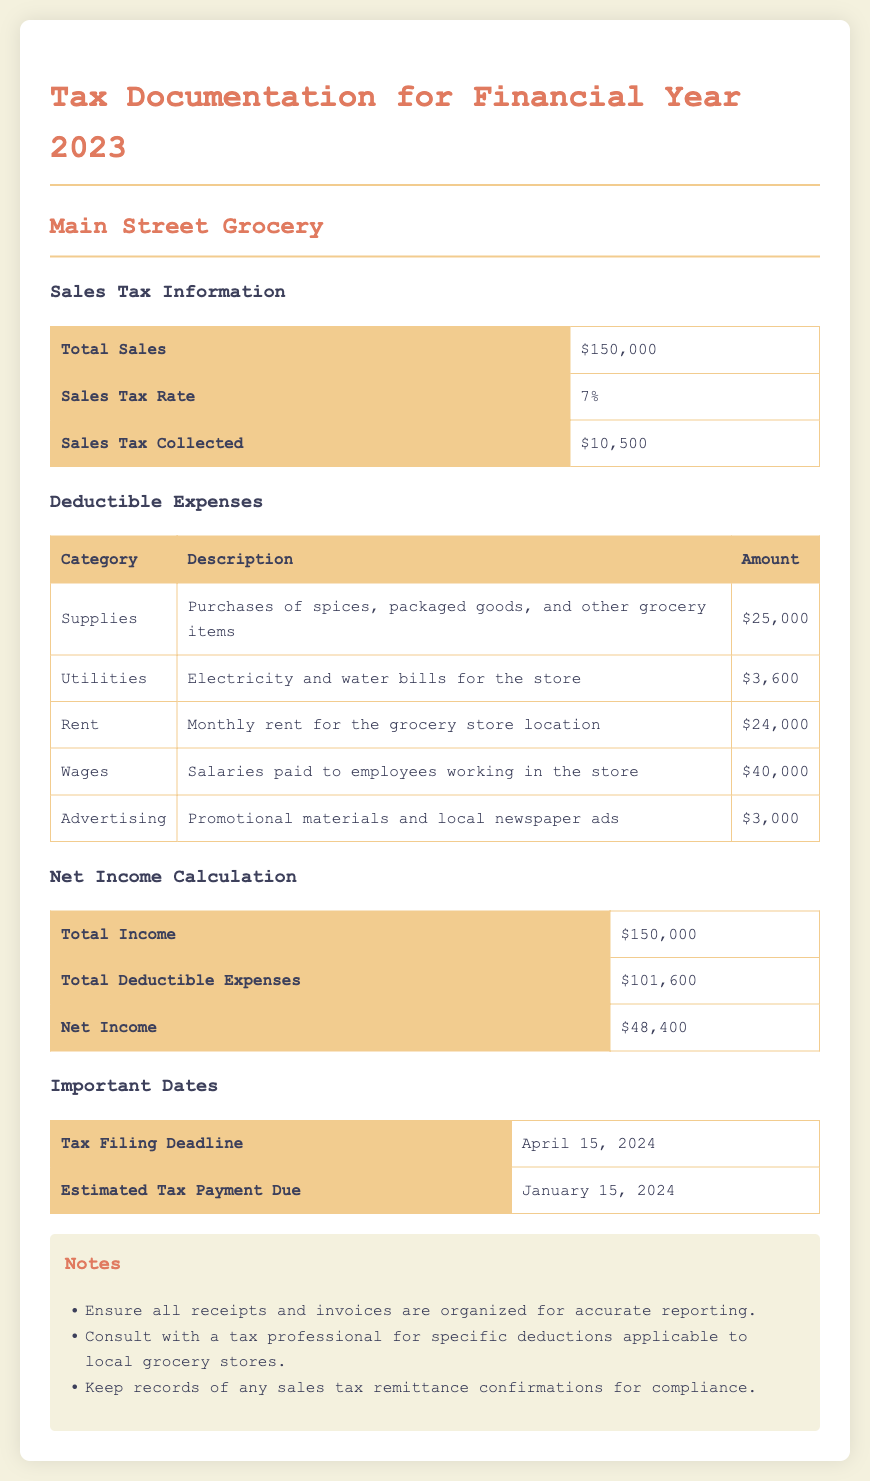what is the total sales? The total sales figure is explicitly reported in the document under Sales Tax Information, which is $150,000.
Answer: $150,000 what is the sales tax rate? The sales tax rate is mentioned in the Sales Tax Information section, which states that it is 7%.
Answer: 7% how much sales tax was collected? The document specifies that the total sales tax collected is $10,500.
Answer: $10,500 what is the total amount spent on supplies? The deductible expenses table clearly lists the amount spent on supplies, which amounts to $25,000.
Answer: $25,000 what is the net income calculation? The net income is calculated in the document by subtracting total deductible expenses from total income, resulting in $48,400.
Answer: $48,400 when is the tax filing deadline? The document lists the tax filing deadline as April 15, 2024, in the Important Dates section.
Answer: April 15, 2024 what are the total deductible expenses? The total deductible expenses are given in the net income calculation section, which states $101,600.
Answer: $101,600 how much was spent on advertising? The deductible expenses table includes the amount spent on advertising, which is $3,000.
Answer: $3,000 what is the due date for estimated tax payment? The due date for estimated tax payment is noted as January 15, 2024, in the Important Dates section.
Answer: January 15, 2024 